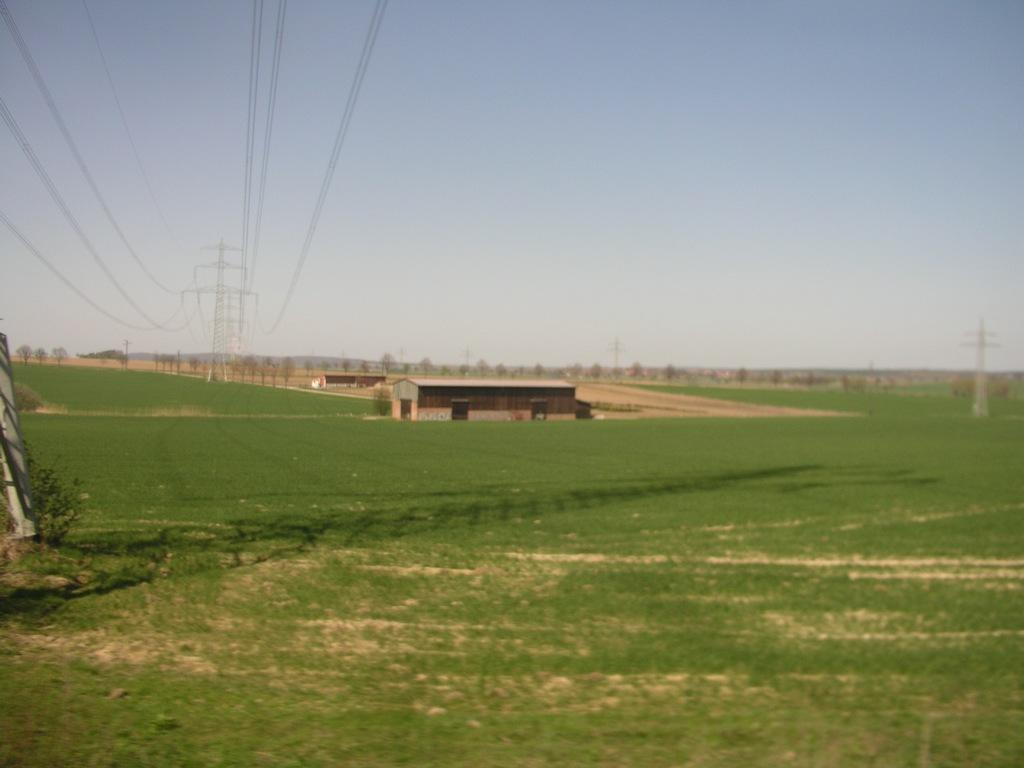What type of structures can be seen in the image? There are buildings and towers in the image. What natural elements are present in the image? There are trees in the image. What type of infrastructure is visible in the image? Cables are visible in the image. What can be seen in the background of the image? The sky is visible in the background of the image. How many maids are present in the image? There are no maids present in the image. What type of beetle can be seen crawling on the buildings in the image? There are no beetles visible in the image; it only features buildings, towers, trees, cables, and the sky. 